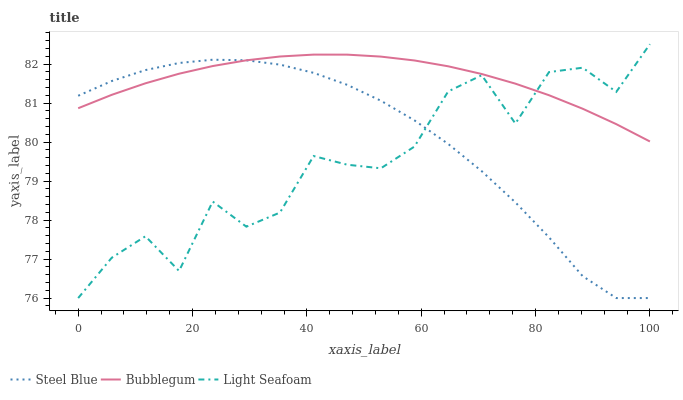Does Light Seafoam have the minimum area under the curve?
Answer yes or no. Yes. Does Bubblegum have the maximum area under the curve?
Answer yes or no. Yes. Does Steel Blue have the minimum area under the curve?
Answer yes or no. No. Does Steel Blue have the maximum area under the curve?
Answer yes or no. No. Is Bubblegum the smoothest?
Answer yes or no. Yes. Is Light Seafoam the roughest?
Answer yes or no. Yes. Is Steel Blue the smoothest?
Answer yes or no. No. Is Steel Blue the roughest?
Answer yes or no. No. Does Light Seafoam have the lowest value?
Answer yes or no. Yes. Does Bubblegum have the lowest value?
Answer yes or no. No. Does Light Seafoam have the highest value?
Answer yes or no. Yes. Does Bubblegum have the highest value?
Answer yes or no. No. Does Steel Blue intersect Light Seafoam?
Answer yes or no. Yes. Is Steel Blue less than Light Seafoam?
Answer yes or no. No. Is Steel Blue greater than Light Seafoam?
Answer yes or no. No. 